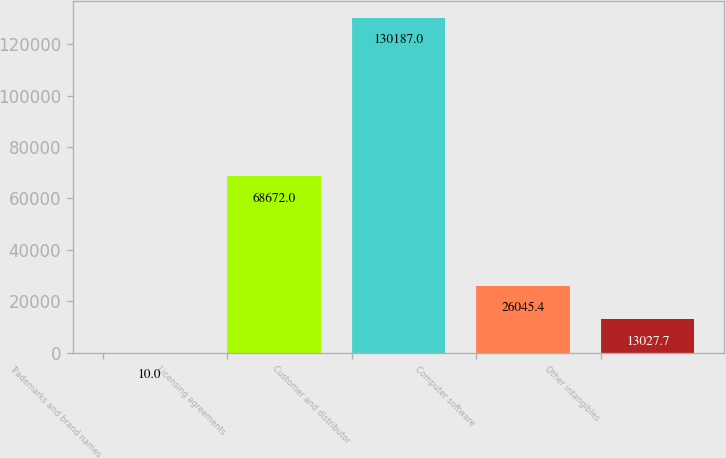Convert chart. <chart><loc_0><loc_0><loc_500><loc_500><bar_chart><fcel>Trademarks and brand names<fcel>Licensing agreements<fcel>Customer and distributor<fcel>Computer software<fcel>Other intangibles<nl><fcel>10<fcel>68672<fcel>130187<fcel>26045.4<fcel>13027.7<nl></chart> 